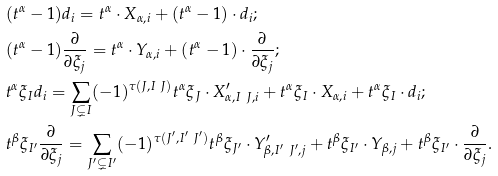<formula> <loc_0><loc_0><loc_500><loc_500>& ( t ^ { \alpha } - 1 ) d _ { i } = t ^ { \alpha } \cdot X _ { \alpha , i } + ( t ^ { \alpha } - 1 ) \cdot d _ { i } ; \\ & ( t ^ { \alpha } - 1 ) \frac { \partial } { \partial \xi _ { j } } = t ^ { \alpha } \cdot Y _ { \alpha , i } + ( t ^ { \alpha } - 1 ) \cdot \frac { \partial } { \partial \xi _ { j } } ; \\ & t ^ { \alpha } \xi _ { I } d _ { i } = \sum _ { J \subsetneq I } ( - 1 ) ^ { \tau ( J , I \ J ) } t ^ { \alpha } \xi _ { J } \cdot X ^ { \prime } _ { \alpha , I \ J , i } + t ^ { \alpha } \xi _ { I } \cdot X _ { \alpha , i } + t ^ { \alpha } \xi _ { I } \cdot d _ { i } ; \\ & t ^ { \beta } \xi _ { I ^ { \prime } } \frac { \partial } { \partial \xi _ { j } } = \sum _ { J ^ { \prime } \subsetneq I ^ { \prime } } ( - 1 ) ^ { \tau ( J ^ { \prime } , I ^ { \prime } \ J ^ { \prime } ) } t ^ { \beta } \xi _ { J ^ { \prime } } \cdot Y ^ { \prime } _ { \beta , I ^ { \prime } \ J ^ { \prime } , j } + t ^ { \beta } \xi _ { I ^ { \prime } } \cdot Y _ { \beta , j } + t ^ { \beta } \xi _ { I ^ { \prime } } \cdot \frac { \partial } { \partial \xi _ { j } } .</formula> 